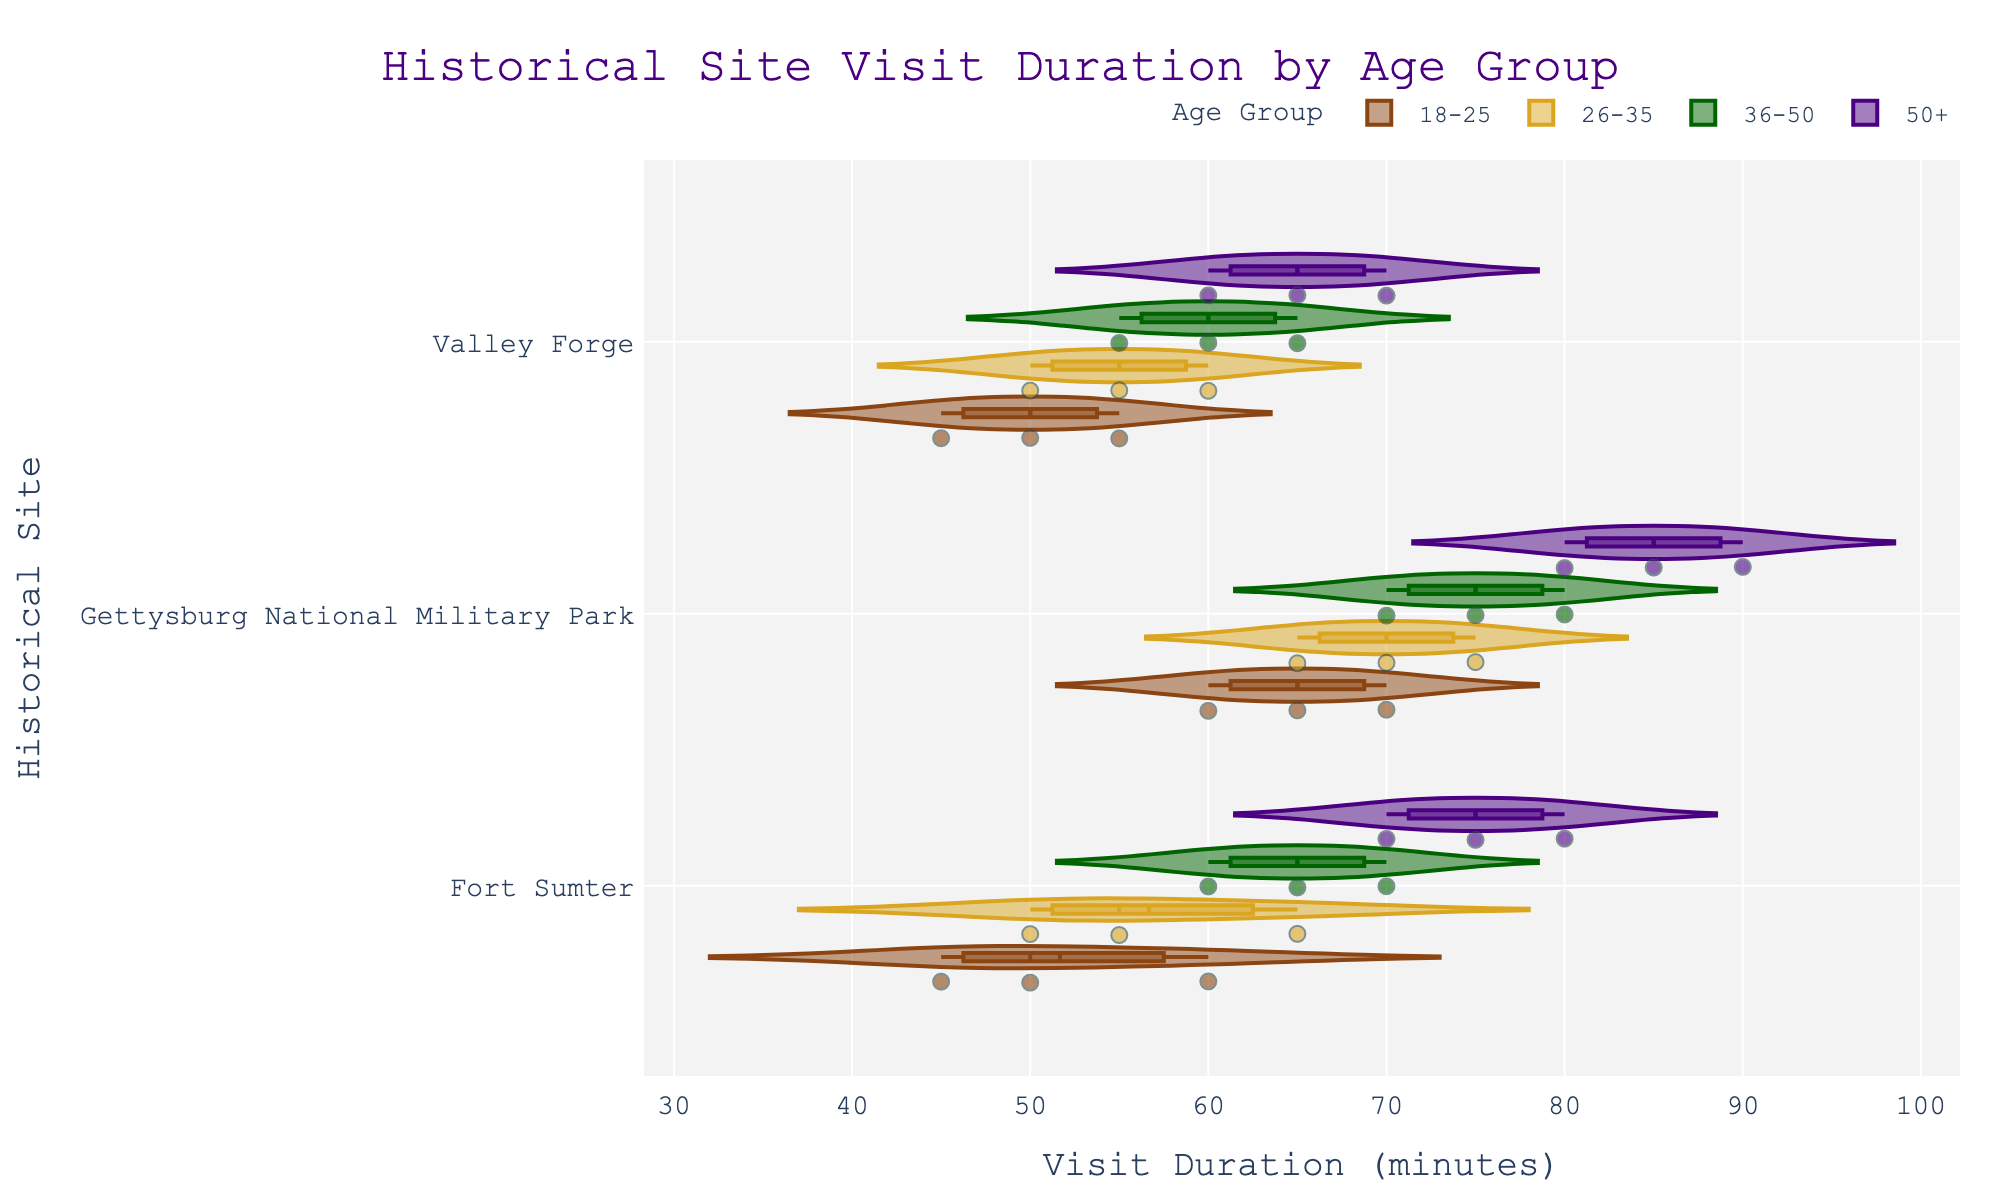What is the title of the figure? The title is prominently displayed at the top center of the figure. The title reads "Historical Site Visit Duration by Age Group".
Answer: Historical Site Visit Duration by Age Group Which age group has the most variable visit durations for Gettysburg National Military Park? By looking at the width and spread of the violin plot for each age group at Gettysburg National Military Park, we can see that the 50+ age group has the widest spread, indicating the most variable visit durations.
Answer: 50+ What is the median visit duration for visitors aged 26-35 at Valley Forge? The box plot inside the violin for the 26-35 age group at Valley Forge shows the median as the middle line in the box. It is at 55 minutes.
Answer: 55 minutes Compare the median visit durations for visitors aged 36-50 and those aged 50+ at Fort Sumter. Which group spends more time on average? By examining the median lines in the box plots for the 36-50 and 50+ age groups at Fort Sumter, we see that the median for 36-50 is at 65 minutes, while for 50+ it is at 75 minutes. Thus, visitors aged 50+ spend more time on average.
Answer: 50+ Which historical site has the highest median visit duration for the 18-25 age group? By examining the median lines in the box plots for the 18-25 age group across all sites, Gettysburg National Military Park has the highest median, around 65 minutes.
Answer: Gettysburg National Military Park Which age group has the smallest spread of visit durations at any site, and what is the site? By looking at the narrowest violin plot indicating the smallest spread, we see the 18-25 age group at Valley Forge has the smallest spread.
Answer: 18-25 at Valley Forge How does the maximum visit duration for the 50+ age group at Valley Forge compare to the minimum visit duration for the 36-50 age group at Gettysburg National Military Park? The maximum visit duration for the 50+ age group at Valley Forge is 70 minutes. The minimum duration for the 36-50 age group at Gettysburg National Military Park is 70 minutes as well. Both values are equal.
Answer: Equal What feature in the violin plots specifically indicates the presence of outliers in the data? Outliers in the data are indicated by individual points that fall outside the main body of the violin plot and are visibly separate from the rest of the data distribution.
Answer: Individual points outside the main body For the 26-35 age group, which site shows the highest concentration (density) of visit durations around the median? By examining the width of the violin plots around the median line, the site with the highest density (narrowest spread around median) is Valley Forge.
Answer: Valley Forge 